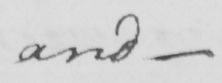Please transcribe the handwritten text in this image. and  _ 